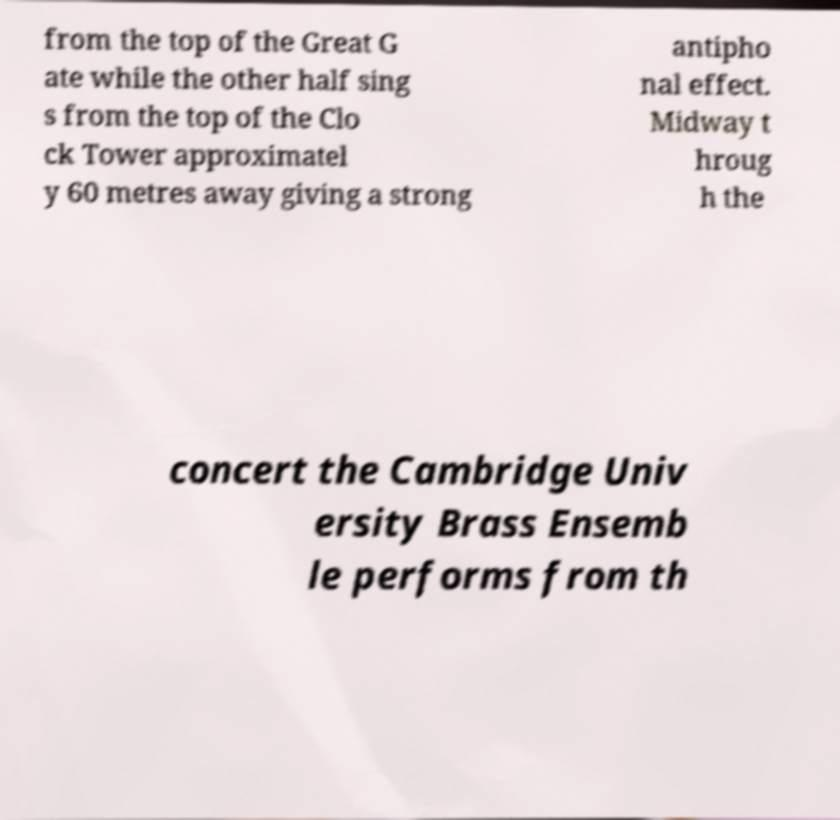Can you read and provide the text displayed in the image?This photo seems to have some interesting text. Can you extract and type it out for me? from the top of the Great G ate while the other half sing s from the top of the Clo ck Tower approximatel y 60 metres away giving a strong antipho nal effect. Midway t hroug h the concert the Cambridge Univ ersity Brass Ensemb le performs from th 